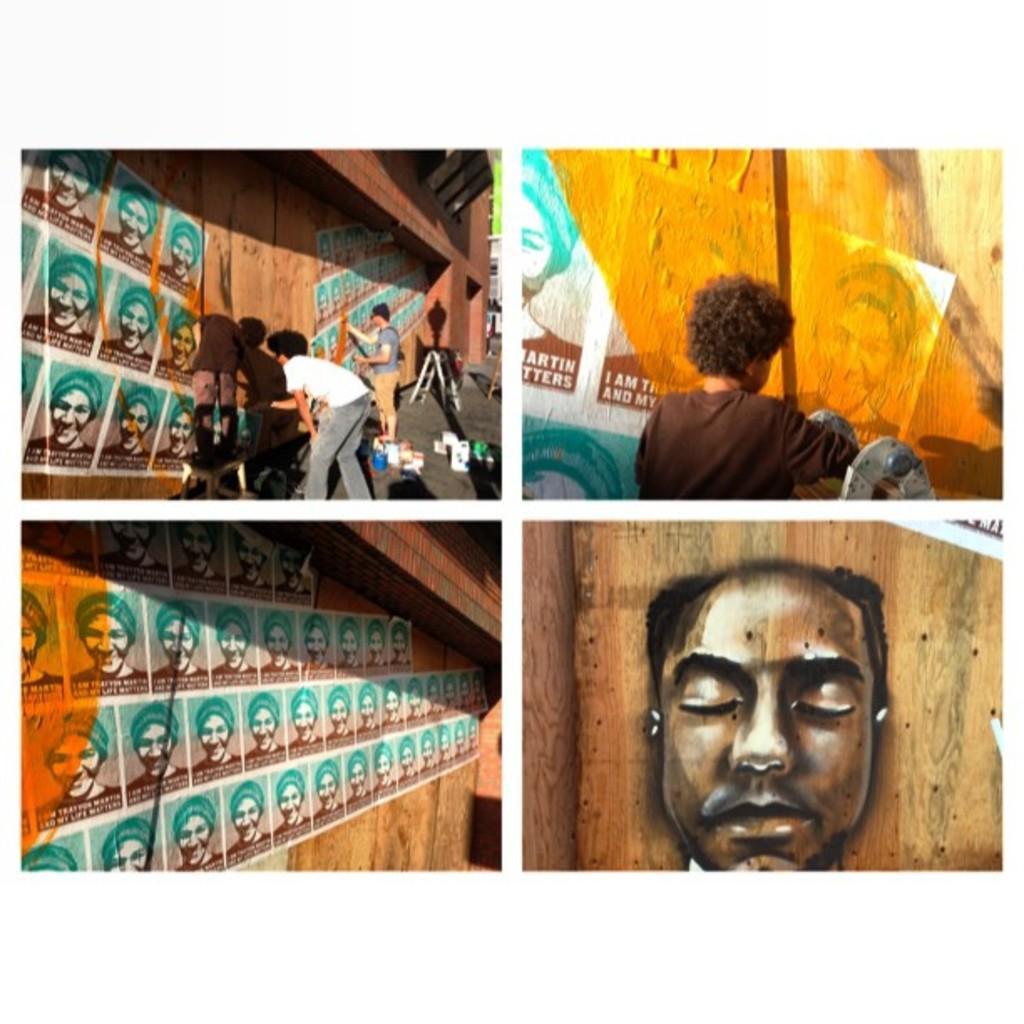In one or two sentences, can you explain what this image depicts? This is a collage, in this image there are some persons and some posters are stick to the wall, and there are some buckets and a wall. 